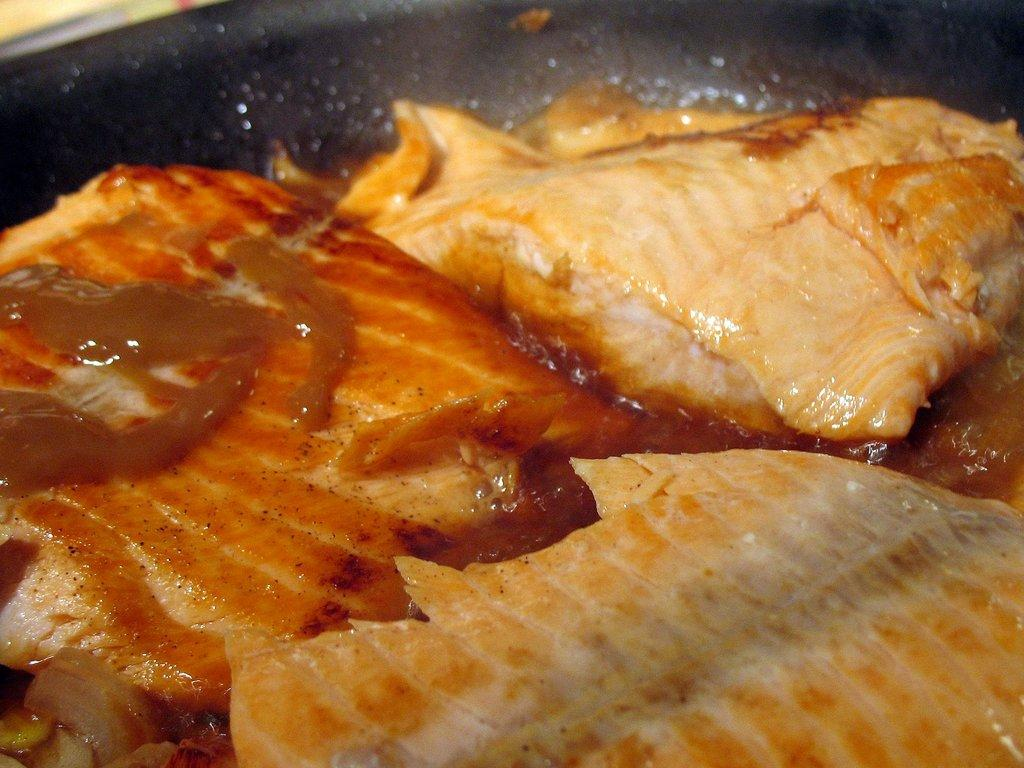What type of food is visible in the image? There is meat in the image. What is covering the meat in the image? The meat has sauce on it. Where is the meat located in the image? The meat is in a pan. What type of teeth can be seen in the image? There are no teeth visible in the image; it features meat with sauce in a pan. 